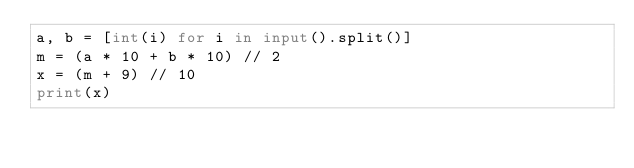Convert code to text. <code><loc_0><loc_0><loc_500><loc_500><_Python_>a, b = [int(i) for i in input().split()]
m = (a * 10 + b * 10) // 2
x = (m + 9) // 10
print(x)</code> 